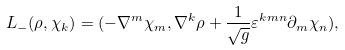<formula> <loc_0><loc_0><loc_500><loc_500>L _ { - } ( \rho , { \chi } _ { k } ) = ( - { \nabla } ^ { m } { \chi } _ { m } , { \nabla } ^ { k } \rho + \frac { 1 } { \sqrt { g } } { \varepsilon } ^ { k m n } { \partial } _ { m } { \chi } _ { n } ) ,</formula> 